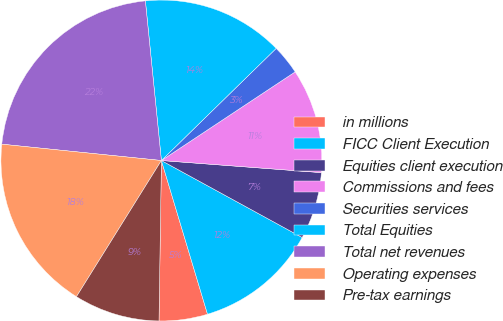Convert chart to OTSL. <chart><loc_0><loc_0><loc_500><loc_500><pie_chart><fcel>in millions<fcel>FICC Client Execution<fcel>Equities client execution<fcel>Commissions and fees<fcel>Securities services<fcel>Total Equities<fcel>Total net revenues<fcel>Operating expenses<fcel>Pre-tax earnings<nl><fcel>4.88%<fcel>12.4%<fcel>6.76%<fcel>10.52%<fcel>3.0%<fcel>14.28%<fcel>21.79%<fcel>17.75%<fcel>8.64%<nl></chart> 